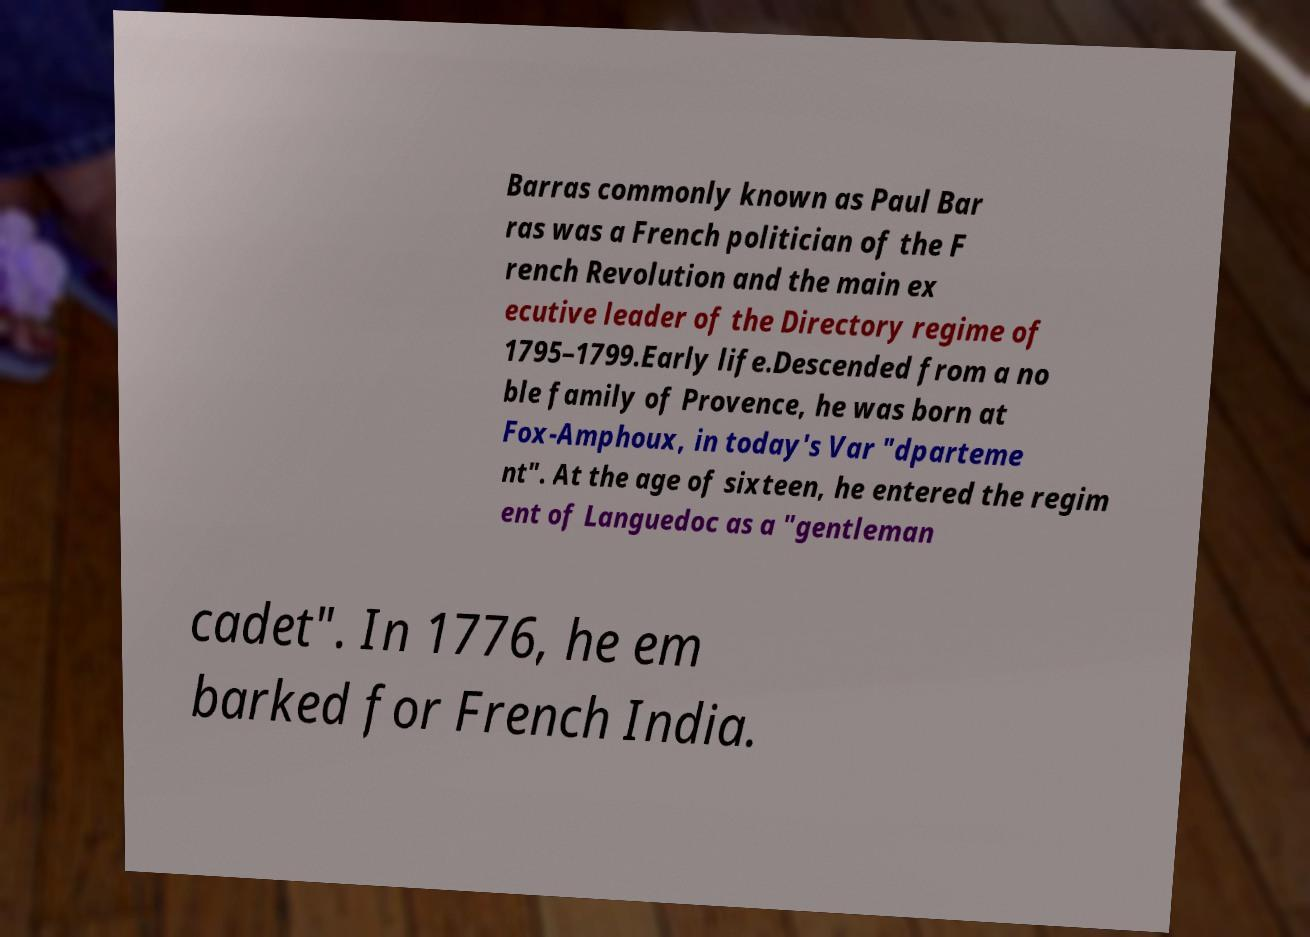Could you extract and type out the text from this image? Barras commonly known as Paul Bar ras was a French politician of the F rench Revolution and the main ex ecutive leader of the Directory regime of 1795–1799.Early life.Descended from a no ble family of Provence, he was born at Fox-Amphoux, in today's Var "dparteme nt". At the age of sixteen, he entered the regim ent of Languedoc as a "gentleman cadet". In 1776, he em barked for French India. 